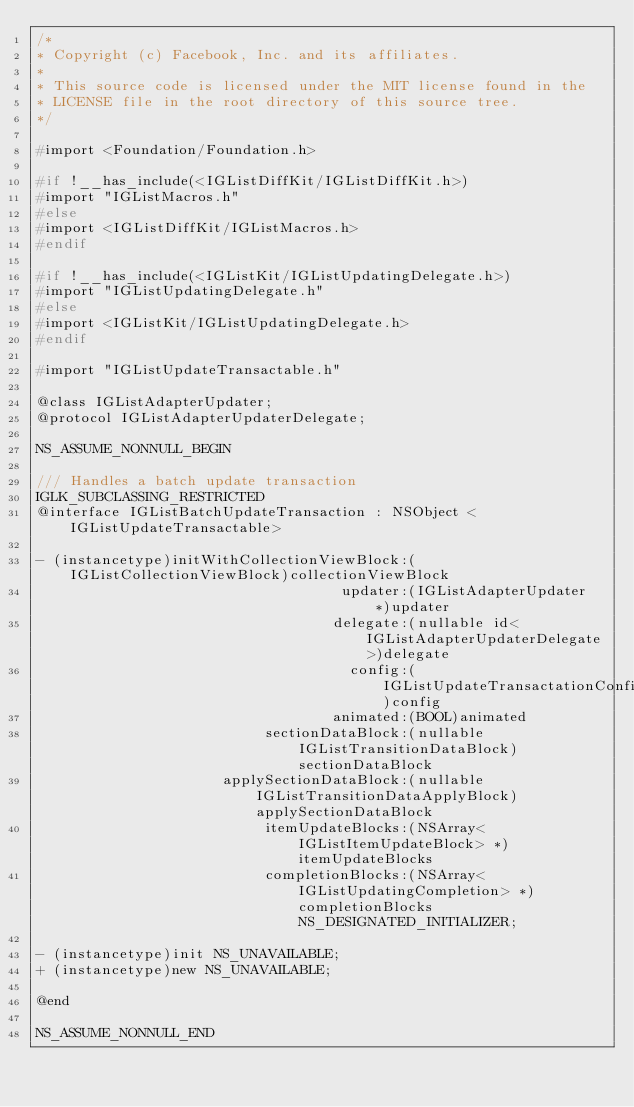<code> <loc_0><loc_0><loc_500><loc_500><_C_>/*
* Copyright (c) Facebook, Inc. and its affiliates.
*
* This source code is licensed under the MIT license found in the
* LICENSE file in the root directory of this source tree.
*/

#import <Foundation/Foundation.h>

#if !__has_include(<IGListDiffKit/IGListDiffKit.h>)
#import "IGListMacros.h"
#else
#import <IGListDiffKit/IGListMacros.h>
#endif

#if !__has_include(<IGListKit/IGListUpdatingDelegate.h>)
#import "IGListUpdatingDelegate.h"
#else
#import <IGListKit/IGListUpdatingDelegate.h>
#endif

#import "IGListUpdateTransactable.h"

@class IGListAdapterUpdater;
@protocol IGListAdapterUpdaterDelegate;

NS_ASSUME_NONNULL_BEGIN

/// Handles a batch update transaction
IGLK_SUBCLASSING_RESTRICTED
@interface IGListBatchUpdateTransaction : NSObject <IGListUpdateTransactable>

- (instancetype)initWithCollectionViewBlock:(IGListCollectionViewBlock)collectionViewBlock
                                    updater:(IGListAdapterUpdater *)updater
                                   delegate:(nullable id<IGListAdapterUpdaterDelegate>)delegate
                                     config:(IGListUpdateTransactationConfig)config
                                   animated:(BOOL)animated
                           sectionDataBlock:(nullable IGListTransitionDataBlock)sectionDataBlock
                      applySectionDataBlock:(nullable IGListTransitionDataApplyBlock)applySectionDataBlock
                           itemUpdateBlocks:(NSArray<IGListItemUpdateBlock> *)itemUpdateBlocks
                           completionBlocks:(NSArray<IGListUpdatingCompletion> *)completionBlocks NS_DESIGNATED_INITIALIZER;

- (instancetype)init NS_UNAVAILABLE;
+ (instancetype)new NS_UNAVAILABLE;

@end

NS_ASSUME_NONNULL_END
</code> 